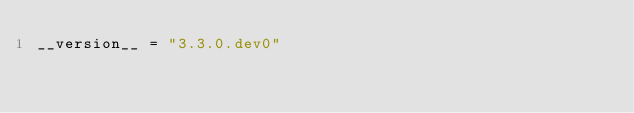Convert code to text. <code><loc_0><loc_0><loc_500><loc_500><_Python_>__version__ = "3.3.0.dev0"
</code> 